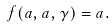<formula> <loc_0><loc_0><loc_500><loc_500>f ( a , a , \gamma ) = a .</formula> 